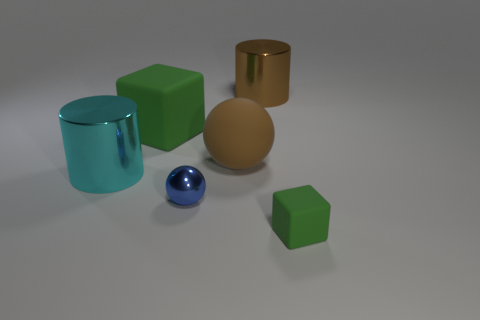Is the number of large brown metallic things on the left side of the small sphere the same as the number of big red cylinders?
Provide a short and direct response. Yes. Is the color of the block that is behind the large rubber ball the same as the small cube right of the small metal sphere?
Ensure brevity in your answer.  Yes. There is a object that is both to the left of the brown matte sphere and behind the matte ball; what material is it?
Keep it short and to the point. Rubber. What color is the big ball?
Provide a succinct answer. Brown. How many other objects are there of the same shape as the big green thing?
Your answer should be compact. 1. Is the number of rubber objects that are behind the large cyan cylinder the same as the number of large brown shiny cylinders that are on the right side of the tiny green thing?
Make the answer very short. No. What is the material of the cyan cylinder?
Your response must be concise. Metal. There is a block in front of the big matte cube; what is its material?
Provide a succinct answer. Rubber. Are there any other things that have the same material as the small green cube?
Give a very brief answer. Yes. Is the number of small rubber blocks on the right side of the tiny blue metal sphere greater than the number of small blue spheres?
Keep it short and to the point. No. 